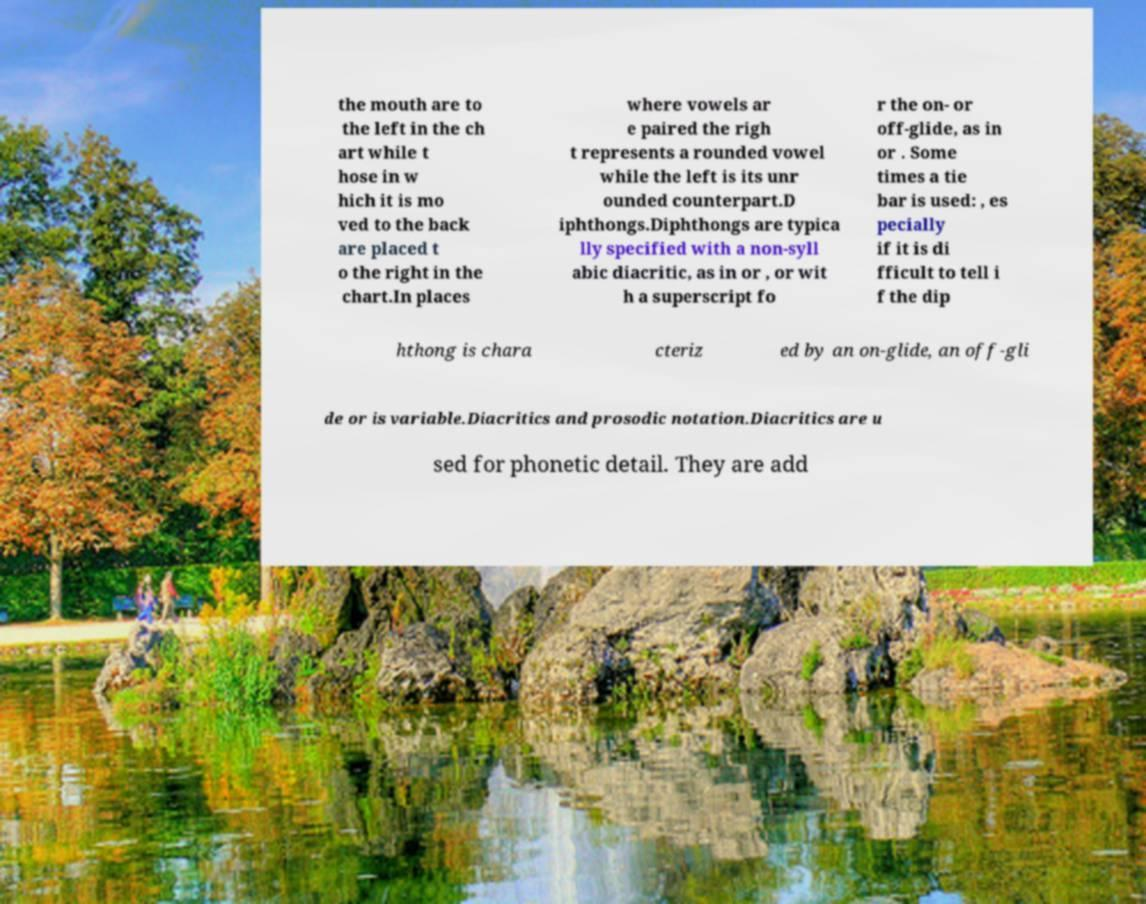Can you read and provide the text displayed in the image?This photo seems to have some interesting text. Can you extract and type it out for me? the mouth are to the left in the ch art while t hose in w hich it is mo ved to the back are placed t o the right in the chart.In places where vowels ar e paired the righ t represents a rounded vowel while the left is its unr ounded counterpart.D iphthongs.Diphthongs are typica lly specified with a non-syll abic diacritic, as in or , or wit h a superscript fo r the on- or off-glide, as in or . Some times a tie bar is used: , es pecially if it is di fficult to tell i f the dip hthong is chara cteriz ed by an on-glide, an off-gli de or is variable.Diacritics and prosodic notation.Diacritics are u sed for phonetic detail. They are add 